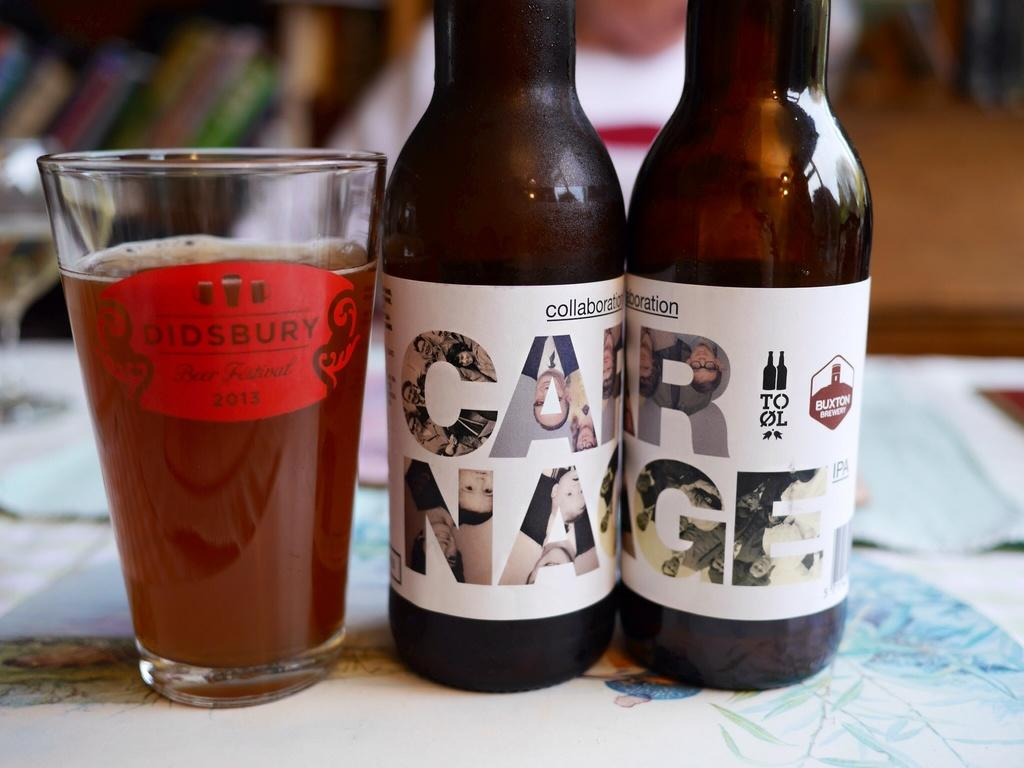<image>
Share a concise interpretation of the image provided. A pint glass of beer is next to two bottles that together spell out the word "carnage". 